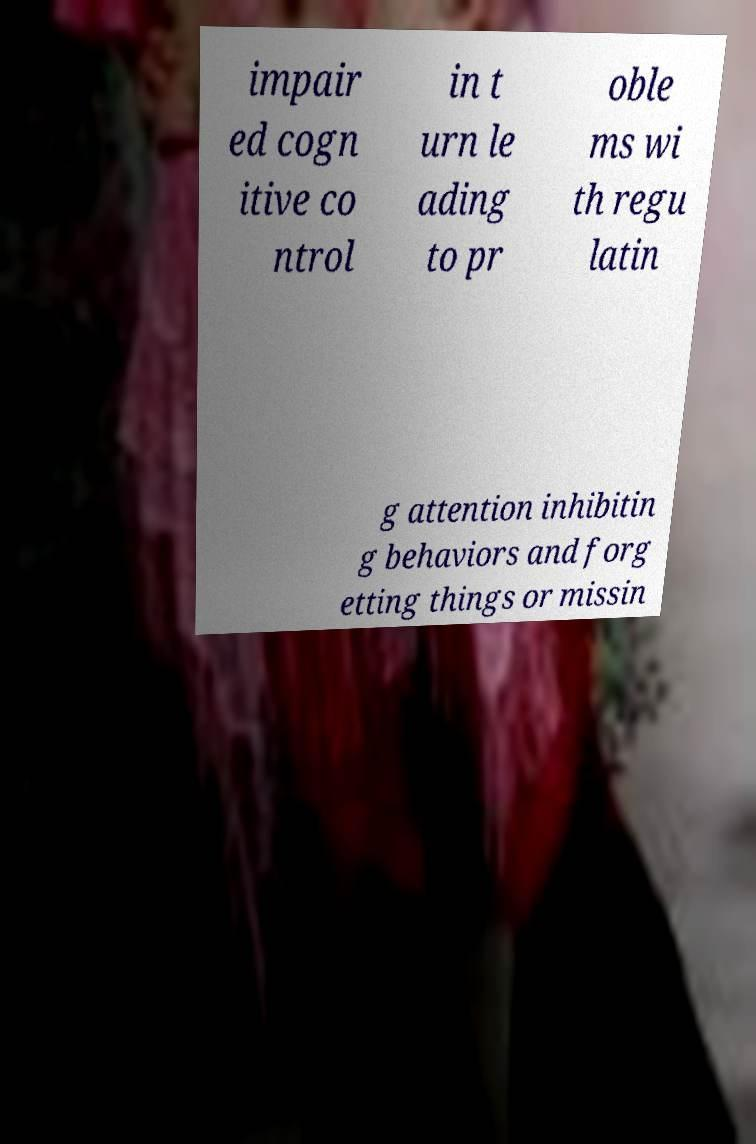Can you read and provide the text displayed in the image?This photo seems to have some interesting text. Can you extract and type it out for me? impair ed cogn itive co ntrol in t urn le ading to pr oble ms wi th regu latin g attention inhibitin g behaviors and forg etting things or missin 